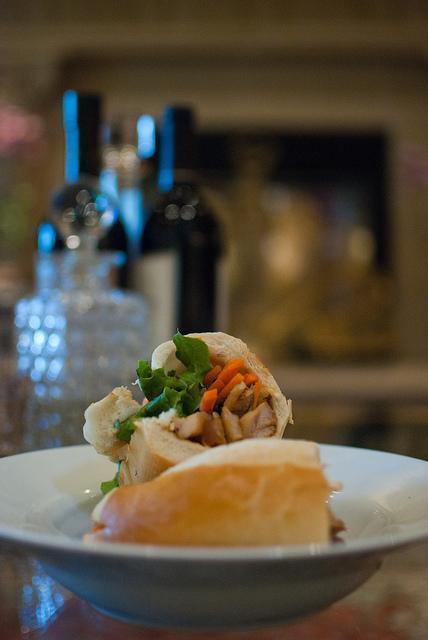Is "The sandwich is in the bowl." an appropriate description for the image?
Answer yes or no. Yes. 